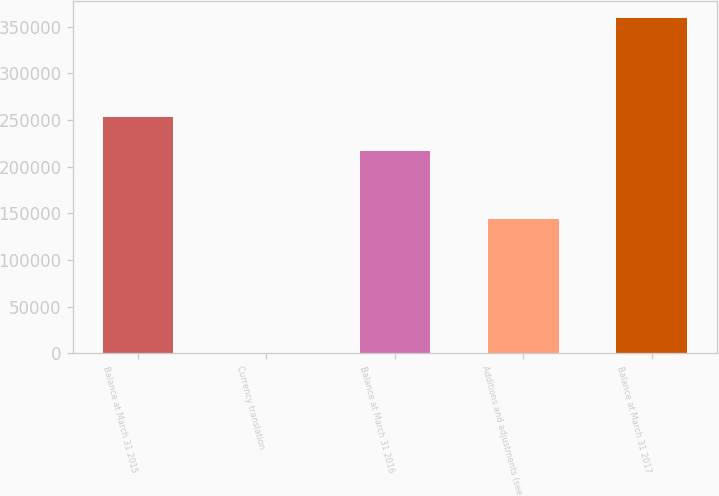Convert chart. <chart><loc_0><loc_0><loc_500><loc_500><bar_chart><fcel>Balance at March 31 2015<fcel>Currency translation<fcel>Balance at March 31 2016<fcel>Additions and adjustments (see<fcel>Balance at March 31 2017<nl><fcel>252971<fcel>208<fcel>217080<fcel>143952<fcel>359115<nl></chart> 